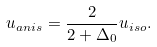Convert formula to latex. <formula><loc_0><loc_0><loc_500><loc_500>u _ { a n i s } = \frac { 2 } { 2 + \Delta _ { 0 } } u _ { i s o } .</formula> 